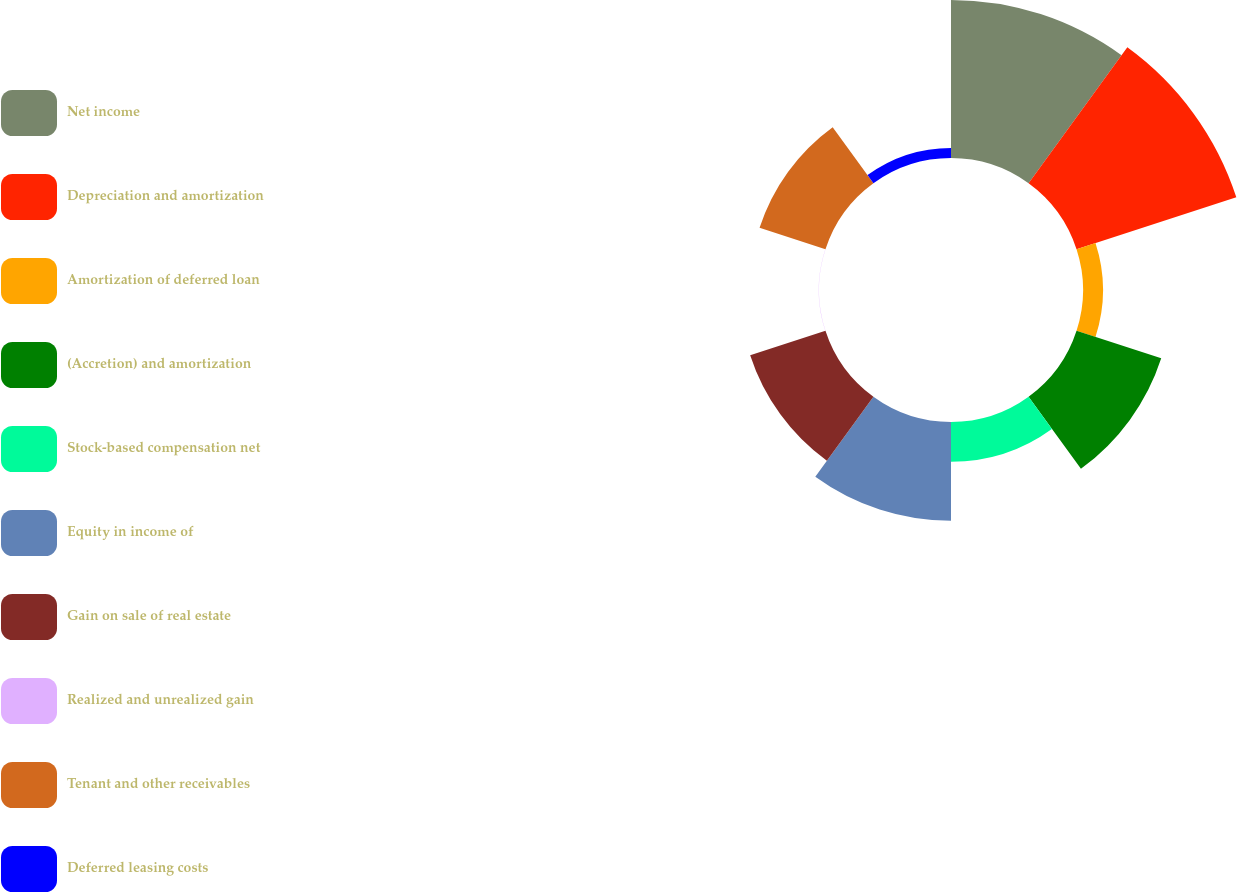<chart> <loc_0><loc_0><loc_500><loc_500><pie_chart><fcel>Net income<fcel>Depreciation and amortization<fcel>Amortization of deferred loan<fcel>(Accretion) and amortization<fcel>Stock-based compensation net<fcel>Equity in income of<fcel>Gain on sale of real estate<fcel>Realized and unrealized gain<fcel>Tenant and other receivables<fcel>Deferred leasing costs<nl><fcel>21.59%<fcel>22.94%<fcel>2.72%<fcel>12.16%<fcel>5.42%<fcel>13.5%<fcel>10.81%<fcel>0.03%<fcel>9.46%<fcel>1.37%<nl></chart> 